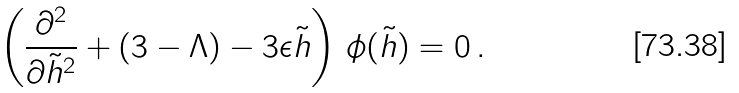<formula> <loc_0><loc_0><loc_500><loc_500>\left ( \frac { \partial ^ { 2 } } { \partial \tilde { h } ^ { 2 } } + ( 3 - \Lambda ) - 3 \epsilon \tilde { h } \right ) \, \phi ( \tilde { h } ) = 0 \, .</formula> 